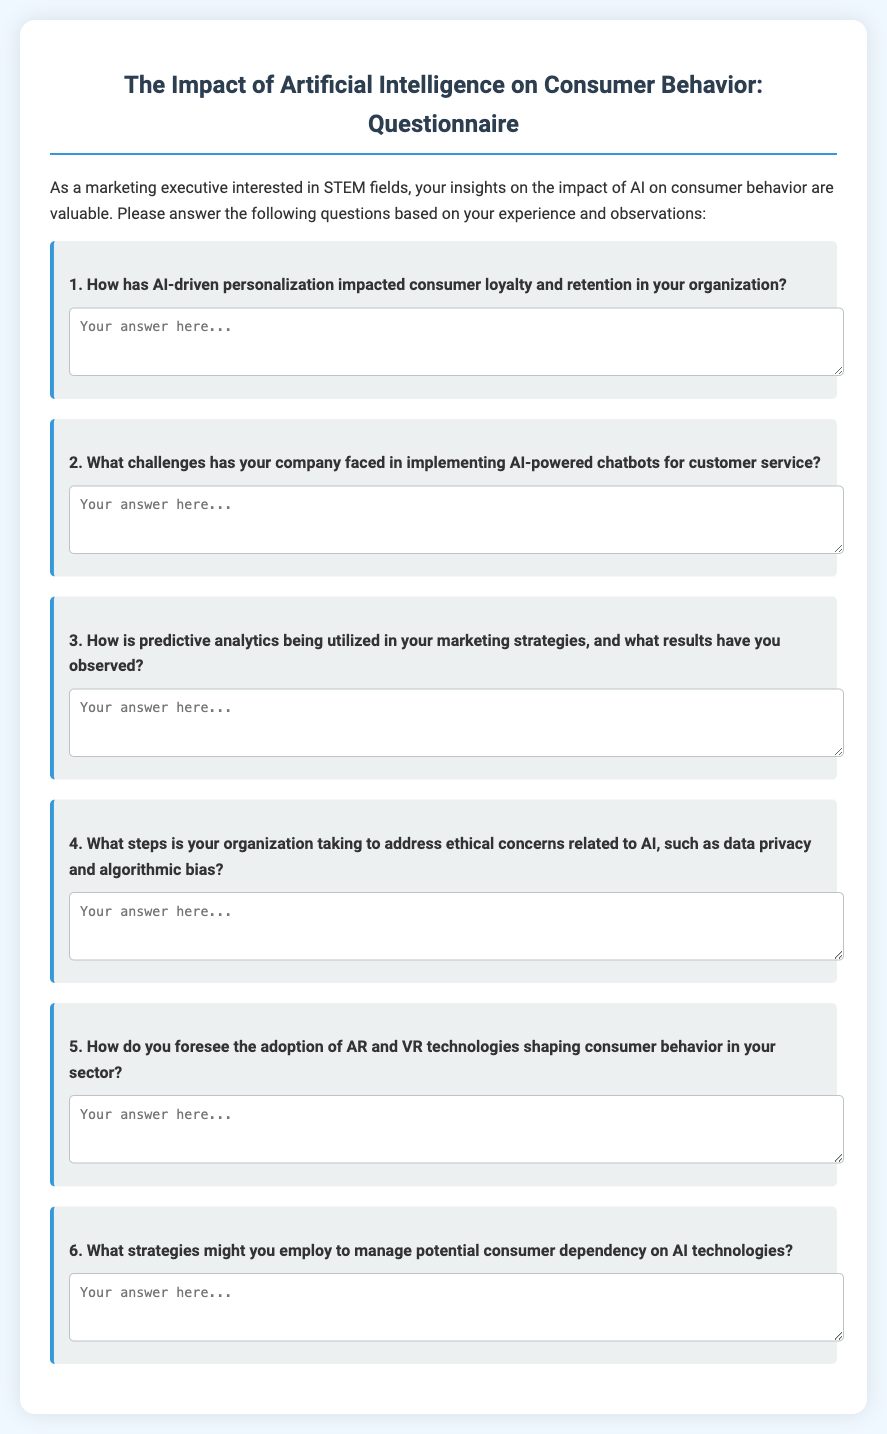What is the title of the questionnaire? The title of the questionnaire is located in the heading of the document.
Answer: The Impact of Artificial Intelligence on Consumer Behavior: Questionnaire How many questions are included in the document? The number of questions can be counted from the sections provided in the questionnaire.
Answer: 6 What is the background color of the document? The background color is indicated in the style section of the document.
Answer: #f0f8ff What technology is specifically mentioned in relation to consumer behavior in the last question? The last question refers to specific technologies impacting consumer behavior.
Answer: AR and VR Which type of consumer behavior does the first question focus on? The first question specifically addresses a key aspect of consumer behavior.
Answer: Loyalty and retention What major concern is the fourth question addressing? The fourth question highlights specific issues that need to be addressed regarding AI technologies.
Answer: Ethical concerns 